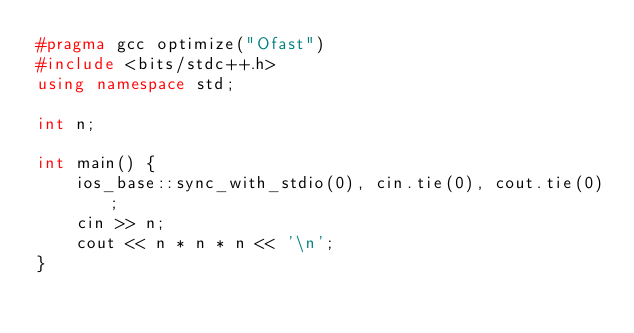Convert code to text. <code><loc_0><loc_0><loc_500><loc_500><_C++_>#pragma gcc optimize("Ofast")
#include <bits/stdc++.h>
using namespace std;

int n;

int main() {
    ios_base::sync_with_stdio(0), cin.tie(0), cout.tie(0);
    cin >> n;
    cout << n * n * n << '\n';
}</code> 